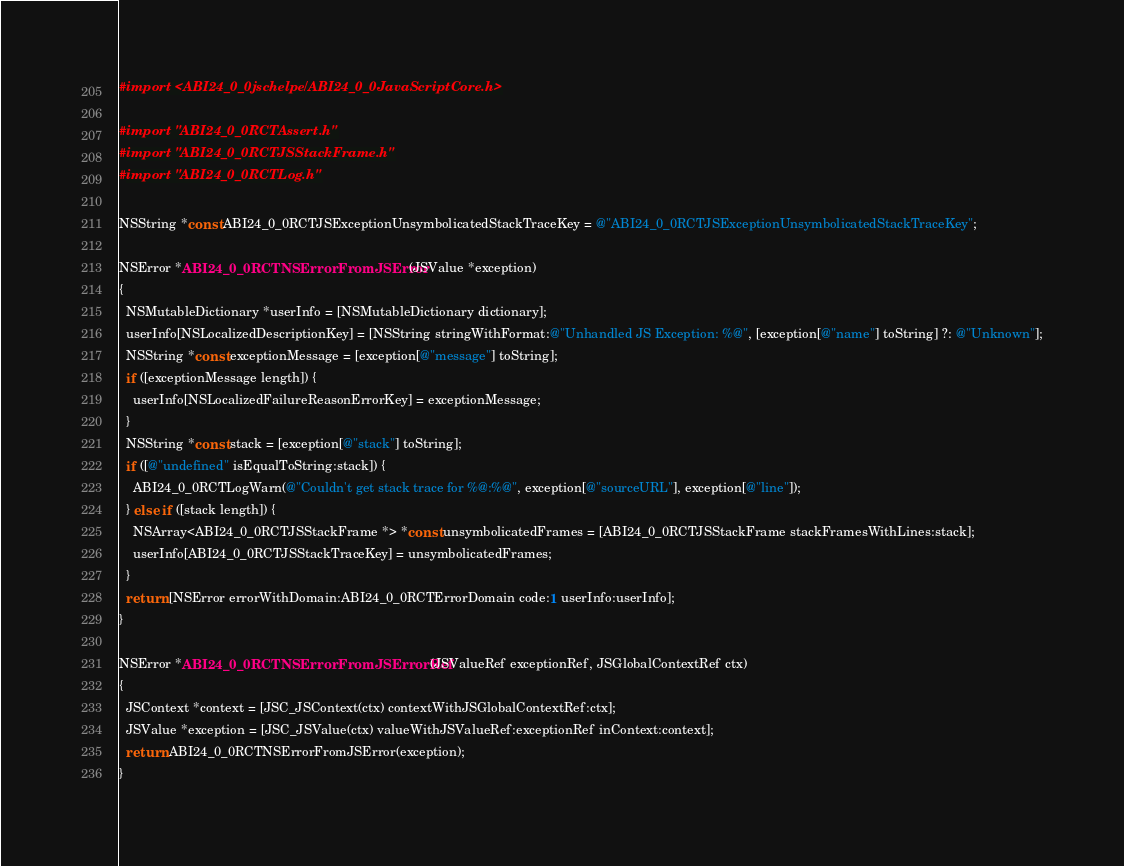Convert code to text. <code><loc_0><loc_0><loc_500><loc_500><_ObjectiveC_>
#import <ABI24_0_0jschelpers/ABI24_0_0JavaScriptCore.h>

#import "ABI24_0_0RCTAssert.h"
#import "ABI24_0_0RCTJSStackFrame.h"
#import "ABI24_0_0RCTLog.h"

NSString *const ABI24_0_0RCTJSExceptionUnsymbolicatedStackTraceKey = @"ABI24_0_0RCTJSExceptionUnsymbolicatedStackTraceKey";

NSError *ABI24_0_0RCTNSErrorFromJSError(JSValue *exception)
{
  NSMutableDictionary *userInfo = [NSMutableDictionary dictionary];
  userInfo[NSLocalizedDescriptionKey] = [NSString stringWithFormat:@"Unhandled JS Exception: %@", [exception[@"name"] toString] ?: @"Unknown"];
  NSString *const exceptionMessage = [exception[@"message"] toString];
  if ([exceptionMessage length]) {
    userInfo[NSLocalizedFailureReasonErrorKey] = exceptionMessage;
  }
  NSString *const stack = [exception[@"stack"] toString];
  if ([@"undefined" isEqualToString:stack]) {
    ABI24_0_0RCTLogWarn(@"Couldn't get stack trace for %@:%@", exception[@"sourceURL"], exception[@"line"]);
  } else if ([stack length]) {
    NSArray<ABI24_0_0RCTJSStackFrame *> *const unsymbolicatedFrames = [ABI24_0_0RCTJSStackFrame stackFramesWithLines:stack];
    userInfo[ABI24_0_0RCTJSStackTraceKey] = unsymbolicatedFrames;
  }
  return [NSError errorWithDomain:ABI24_0_0RCTErrorDomain code:1 userInfo:userInfo];
}

NSError *ABI24_0_0RCTNSErrorFromJSErrorRef(JSValueRef exceptionRef, JSGlobalContextRef ctx)
{
  JSContext *context = [JSC_JSContext(ctx) contextWithJSGlobalContextRef:ctx];
  JSValue *exception = [JSC_JSValue(ctx) valueWithJSValueRef:exceptionRef inContext:context];
  return ABI24_0_0RCTNSErrorFromJSError(exception);
}
</code> 